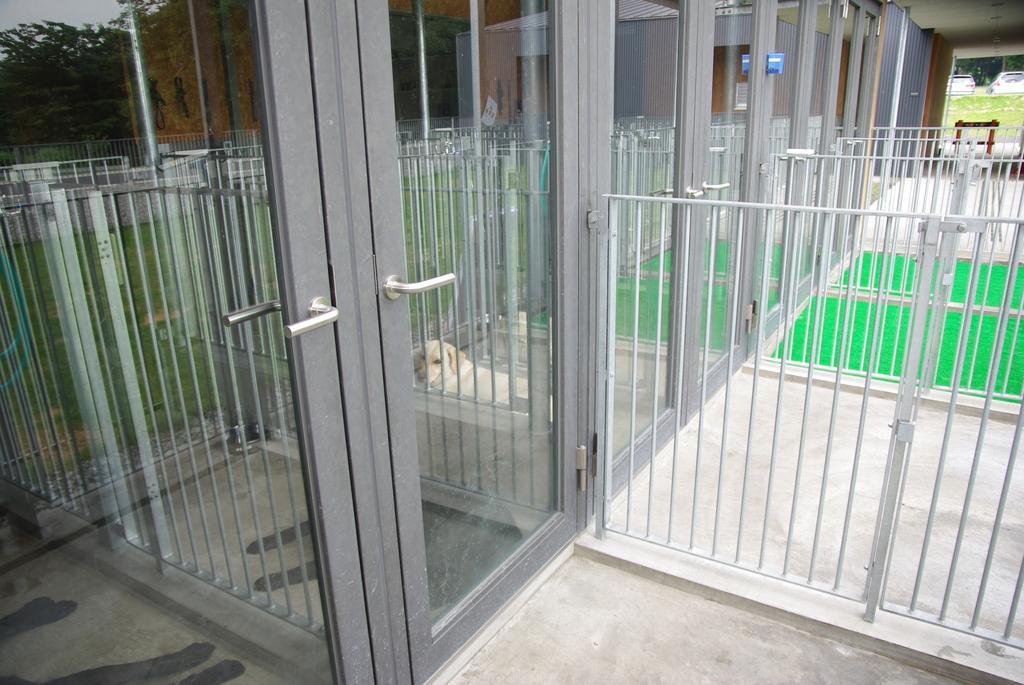In one or two sentences, can you explain what this image depicts? There is a door. There is a safety grill. There is a dog in the image. 